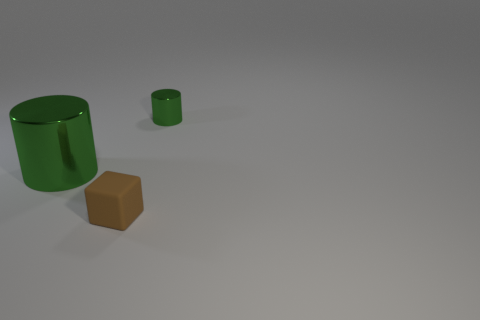Add 1 big metal cylinders. How many objects exist? 4 Subtract all cylinders. How many objects are left? 1 Subtract all large brown shiny spheres. Subtract all tiny matte objects. How many objects are left? 2 Add 2 rubber blocks. How many rubber blocks are left? 3 Add 1 small matte blocks. How many small matte blocks exist? 2 Subtract 0 brown spheres. How many objects are left? 3 